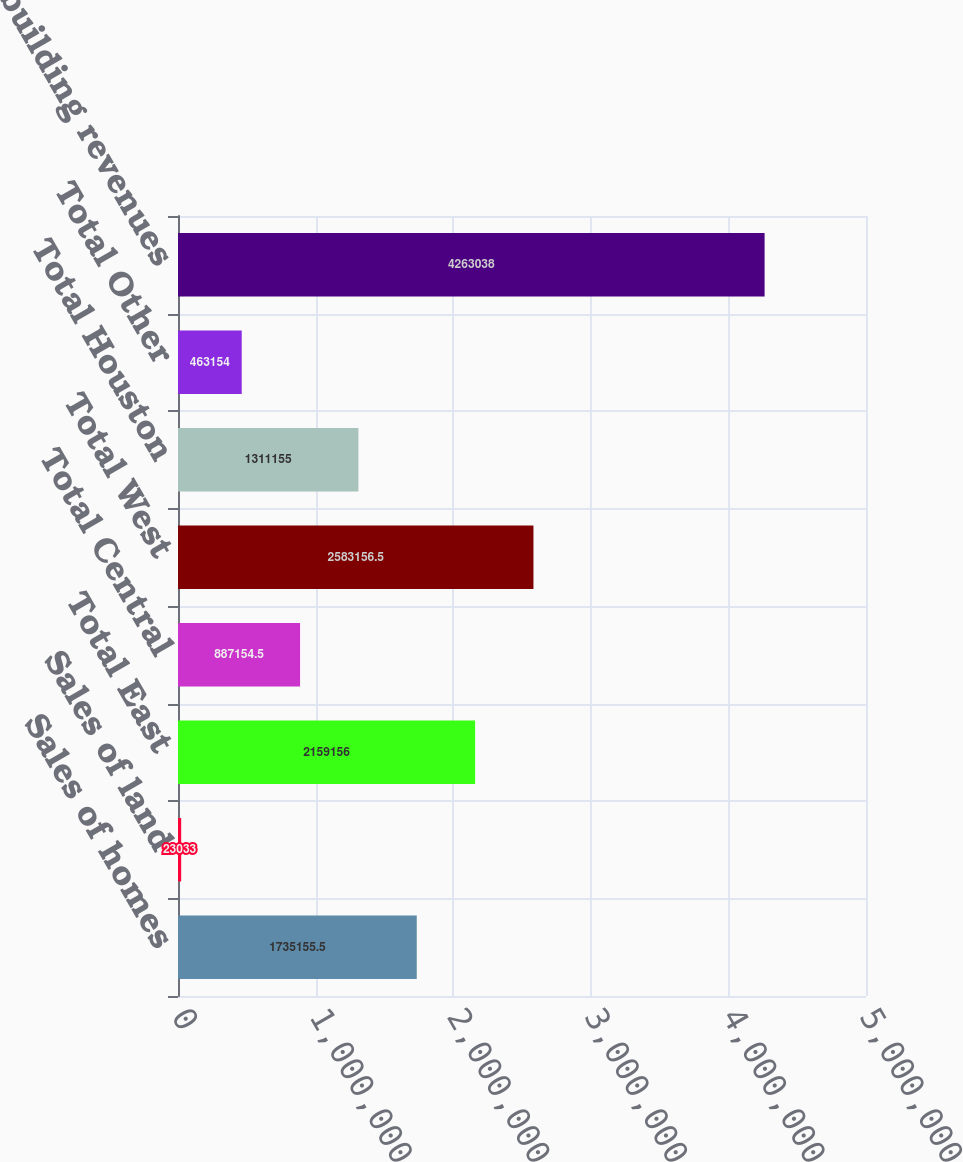<chart> <loc_0><loc_0><loc_500><loc_500><bar_chart><fcel>Sales of homes<fcel>Sales of land<fcel>Total East<fcel>Total Central<fcel>Total West<fcel>Total Houston<fcel>Total Other<fcel>Total homebuilding revenues<nl><fcel>1.73516e+06<fcel>23033<fcel>2.15916e+06<fcel>887154<fcel>2.58316e+06<fcel>1.31116e+06<fcel>463154<fcel>4.26304e+06<nl></chart> 